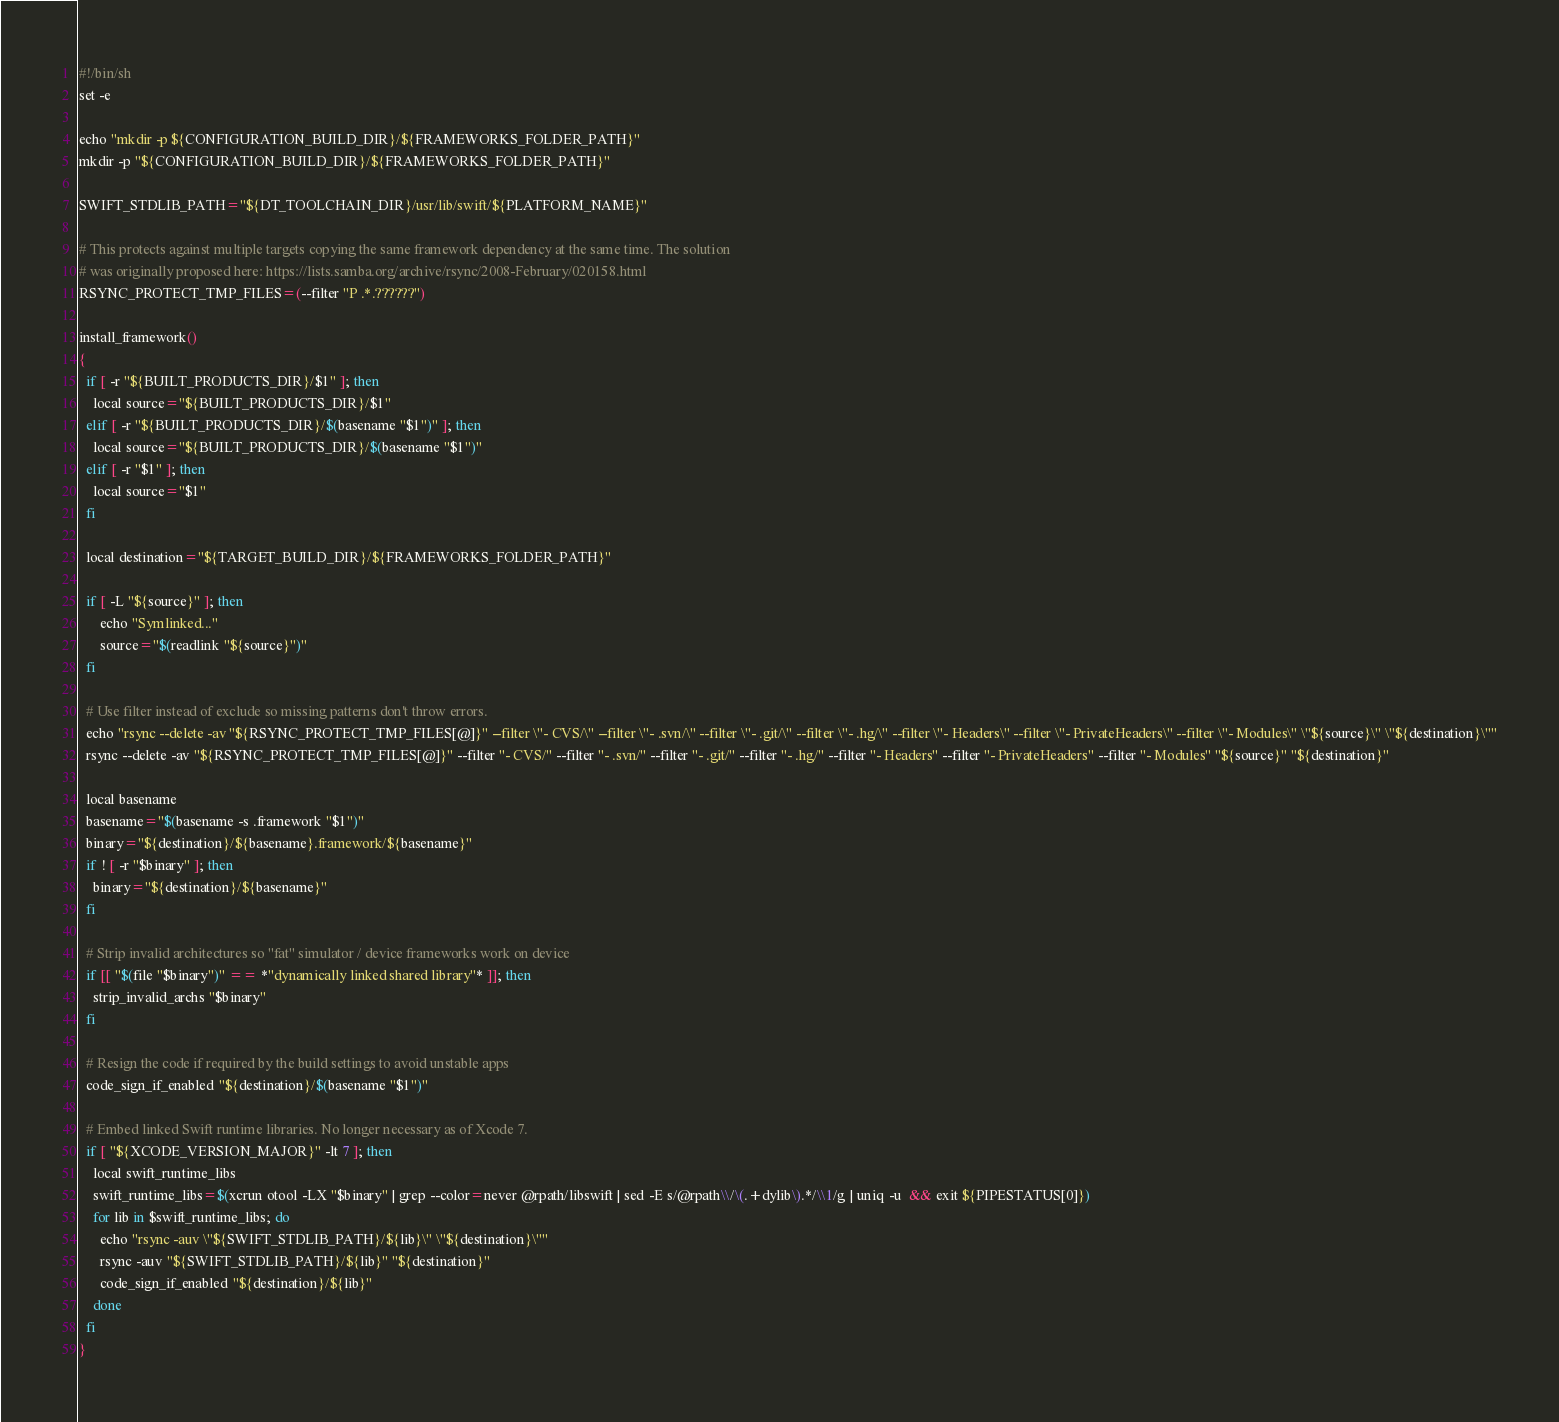Convert code to text. <code><loc_0><loc_0><loc_500><loc_500><_Bash_>#!/bin/sh
set -e

echo "mkdir -p ${CONFIGURATION_BUILD_DIR}/${FRAMEWORKS_FOLDER_PATH}"
mkdir -p "${CONFIGURATION_BUILD_DIR}/${FRAMEWORKS_FOLDER_PATH}"

SWIFT_STDLIB_PATH="${DT_TOOLCHAIN_DIR}/usr/lib/swift/${PLATFORM_NAME}"

# This protects against multiple targets copying the same framework dependency at the same time. The solution
# was originally proposed here: https://lists.samba.org/archive/rsync/2008-February/020158.html
RSYNC_PROTECT_TMP_FILES=(--filter "P .*.??????")

install_framework()
{
  if [ -r "${BUILT_PRODUCTS_DIR}/$1" ]; then
    local source="${BUILT_PRODUCTS_DIR}/$1"
  elif [ -r "${BUILT_PRODUCTS_DIR}/$(basename "$1")" ]; then
    local source="${BUILT_PRODUCTS_DIR}/$(basename "$1")"
  elif [ -r "$1" ]; then
    local source="$1"
  fi

  local destination="${TARGET_BUILD_DIR}/${FRAMEWORKS_FOLDER_PATH}"

  if [ -L "${source}" ]; then
      echo "Symlinked..."
      source="$(readlink "${source}")"
  fi

  # Use filter instead of exclude so missing patterns don't throw errors.
  echo "rsync --delete -av "${RSYNC_PROTECT_TMP_FILES[@]}" --filter \"- CVS/\" --filter \"- .svn/\" --filter \"- .git/\" --filter \"- .hg/\" --filter \"- Headers\" --filter \"- PrivateHeaders\" --filter \"- Modules\" \"${source}\" \"${destination}\""
  rsync --delete -av "${RSYNC_PROTECT_TMP_FILES[@]}" --filter "- CVS/" --filter "- .svn/" --filter "- .git/" --filter "- .hg/" --filter "- Headers" --filter "- PrivateHeaders" --filter "- Modules" "${source}" "${destination}"

  local basename
  basename="$(basename -s .framework "$1")"
  binary="${destination}/${basename}.framework/${basename}"
  if ! [ -r "$binary" ]; then
    binary="${destination}/${basename}"
  fi

  # Strip invalid architectures so "fat" simulator / device frameworks work on device
  if [[ "$(file "$binary")" == *"dynamically linked shared library"* ]]; then
    strip_invalid_archs "$binary"
  fi

  # Resign the code if required by the build settings to avoid unstable apps
  code_sign_if_enabled "${destination}/$(basename "$1")"

  # Embed linked Swift runtime libraries. No longer necessary as of Xcode 7.
  if [ "${XCODE_VERSION_MAJOR}" -lt 7 ]; then
    local swift_runtime_libs
    swift_runtime_libs=$(xcrun otool -LX "$binary" | grep --color=never @rpath/libswift | sed -E s/@rpath\\/\(.+dylib\).*/\\1/g | uniq -u  && exit ${PIPESTATUS[0]})
    for lib in $swift_runtime_libs; do
      echo "rsync -auv \"${SWIFT_STDLIB_PATH}/${lib}\" \"${destination}\""
      rsync -auv "${SWIFT_STDLIB_PATH}/${lib}" "${destination}"
      code_sign_if_enabled "${destination}/${lib}"
    done
  fi
}
</code> 